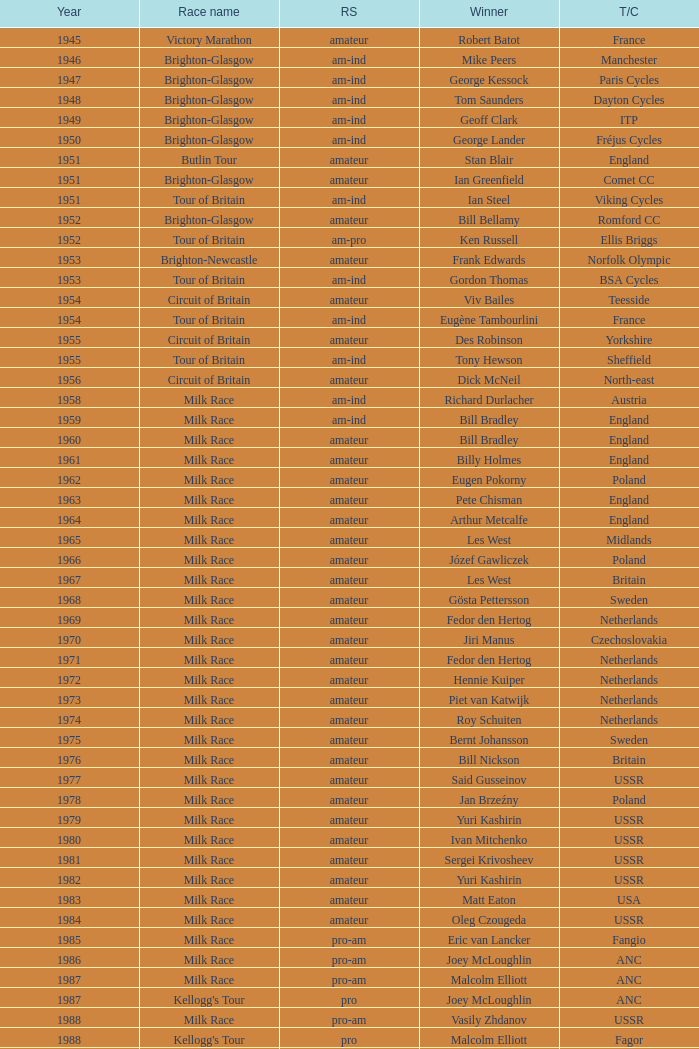What is the rider status for the 1971 netherlands team? Amateur. 